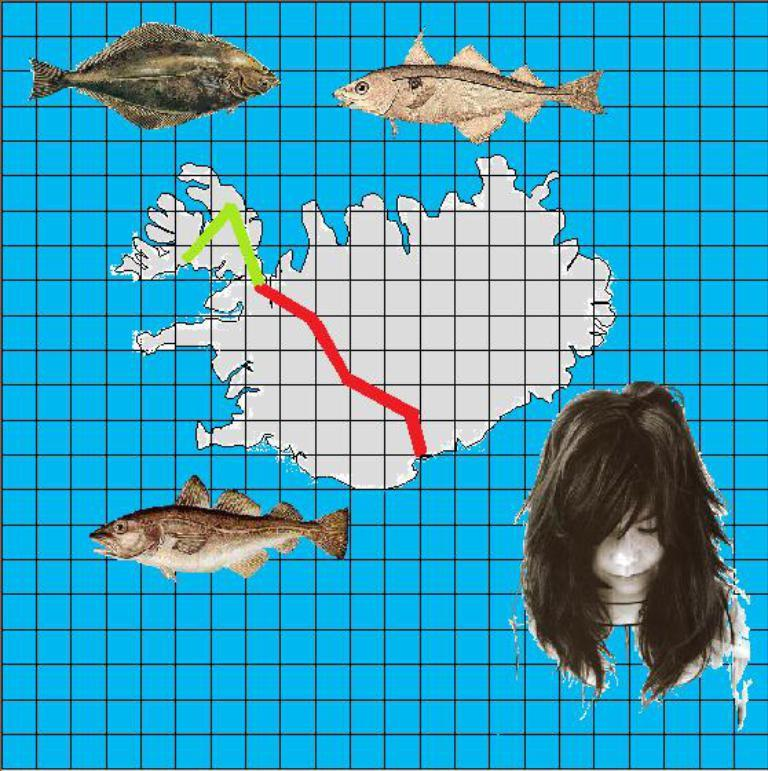What type of image is being described? The image is animated. What can be seen swimming in the image? There are different types of fishes in the image. Is there a human figure present in the image? Yes, there is a girl image in the image. What kind of object is present that shows locations or directions? There is a map in the image. How are the elements arranged in the image? The elements are pasted on a grid boxes background. What type of plantation can be seen in the image? There is no plantation present in the image; it features an animated scene with fishes, a girl image, a map, and a grid boxes background. 